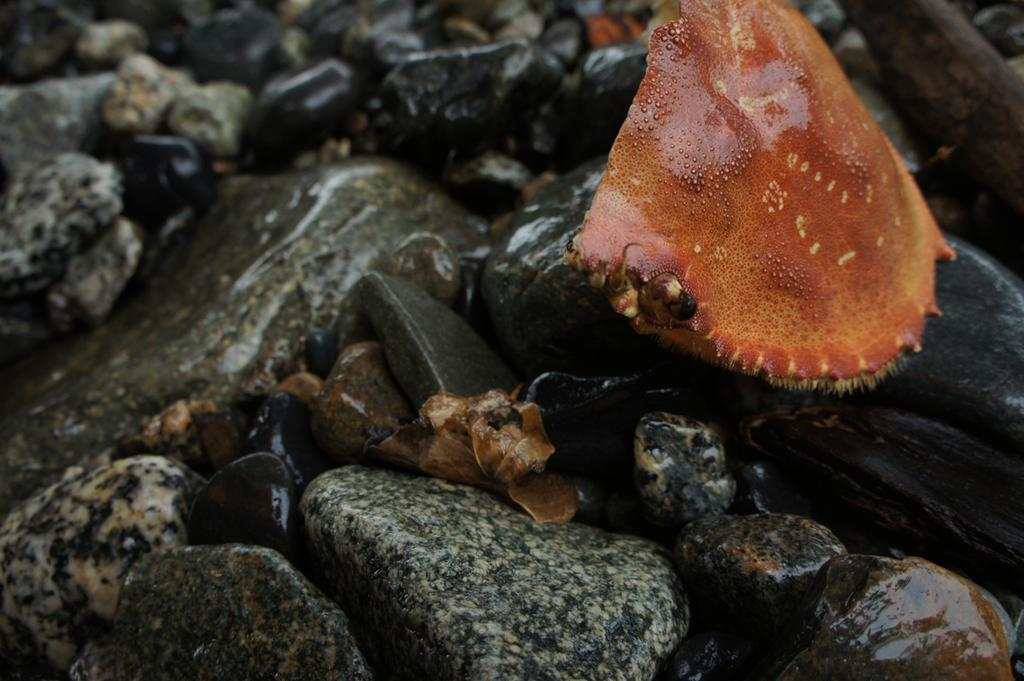Where was the image taken? The image is taken in the water. What type of animal can be seen on the right side of the image? There is a water mammal on the right side of the image. What can be seen at the bottom of the image? There are stones visible at the bottom of the image. What musical instrument is the snake playing in the image? There is no snake or musical instrument present in the image. 